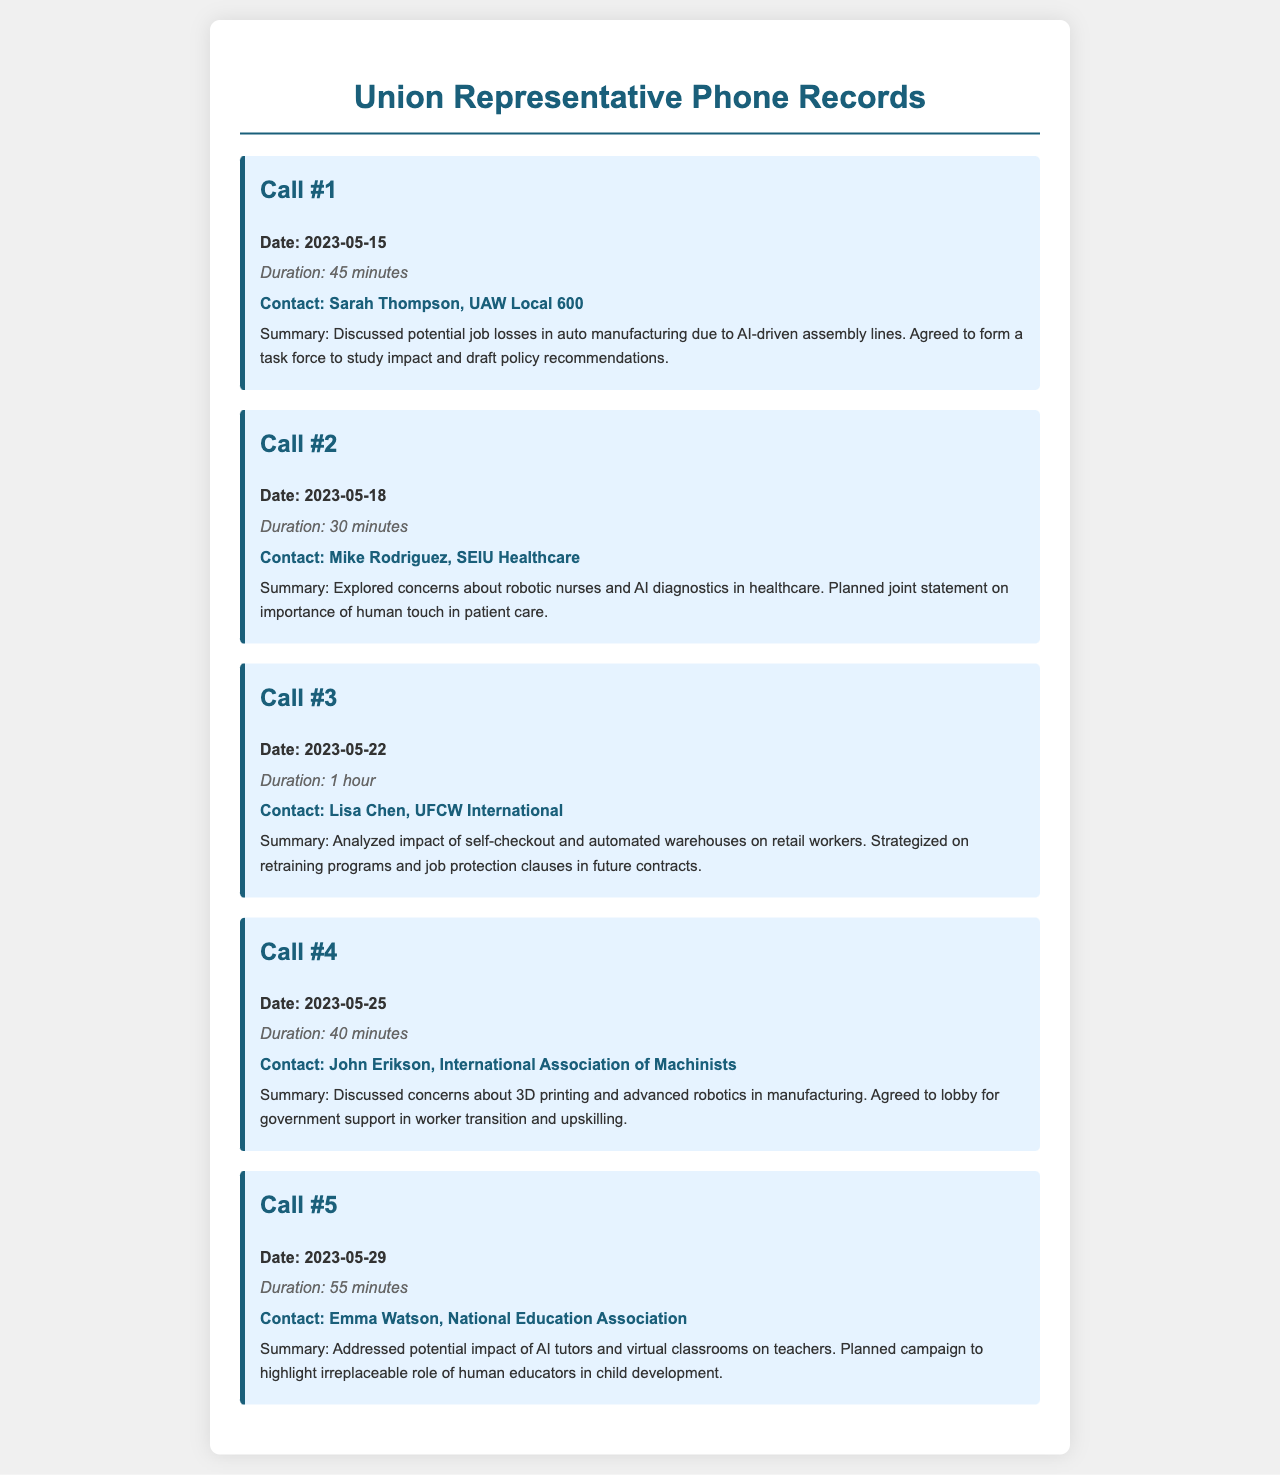what was the date of the first call? The date of the first call is explicitly stated in the document under Call #1.
Answer: 2023-05-15 who was contacted in the second call? The contact name for the second call is listed in the summary of Call #2.
Answer: Mike Rodriguez what was the duration of the third call? The duration of the third call is mentioned in the details of Call #3.
Answer: 1 hour which organization does Sarah Thompson represent? Sarah Thompson's affiliation is specified in the contact information of Call #1.
Answer: UAW Local 600 what main concern was discussed in the fourth call? The main concern discussed in Call #4 is mentioned in the summary, which requires reading the details.
Answer: 3D printing and advanced robotics how many calls discussed the impact of automation on job roles? It requires counting the calls that mentioned job impacts due to automation in their summaries.
Answer: 5 what was the focus of the joint statement planned in the second call? The focus of the joint statement is explicitly stated in the summary of Call #2.
Answer: human touch in patient care which call had the shortest duration? The duration for each call is specified and requires comparing each duration to find the shortest.
Answer: 30 minutes what action was agreed upon in the third call? The agreed action is specifically stated in the summary of Call #3.
Answer: retraining programs and job protection clauses in future contracts 